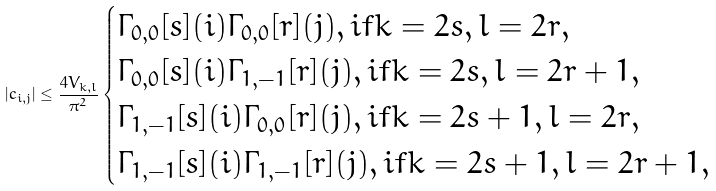<formula> <loc_0><loc_0><loc_500><loc_500>| c _ { i , j } | \leq \frac { 4 V _ { k , l } } { \pi ^ { 2 } } \begin{cases} \Gamma _ { 0 , 0 } [ s ] ( i ) \Gamma _ { 0 , 0 } [ r ] ( j ) , i f k = 2 s , l = 2 r , \\ \Gamma _ { 0 , 0 } [ s ] ( i ) \Gamma _ { 1 , - 1 } [ r ] ( j ) , i f k = 2 s , l = 2 r + 1 , \\ \Gamma _ { 1 , - 1 } [ s ] ( i ) \Gamma _ { 0 , 0 } [ r ] ( j ) , i f k = 2 s + 1 , l = 2 r , \\ \Gamma _ { 1 , - 1 } [ s ] ( i ) \Gamma _ { 1 , - 1 } [ r ] ( j ) , i f k = 2 s + 1 , l = 2 r + 1 , \end{cases}</formula> 